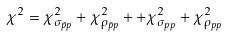<formula> <loc_0><loc_0><loc_500><loc_500>\chi ^ { 2 } = \chi _ { \sigma _ { \bar { p } p } } ^ { 2 } + \chi _ { \rho _ { \bar { p } p } } ^ { 2 } + + \chi _ { \sigma _ { p p } } ^ { 2 } + \chi _ { \rho _ { p p } } ^ { 2 }</formula> 